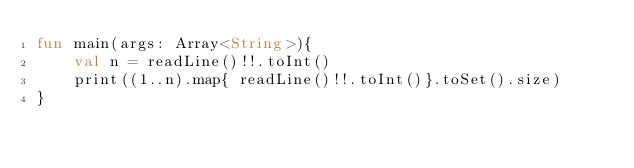Convert code to text. <code><loc_0><loc_0><loc_500><loc_500><_Kotlin_>fun main(args: Array<String>){
    val n = readLine()!!.toInt()
    print((1..n).map{ readLine()!!.toInt()}.toSet().size)
}</code> 